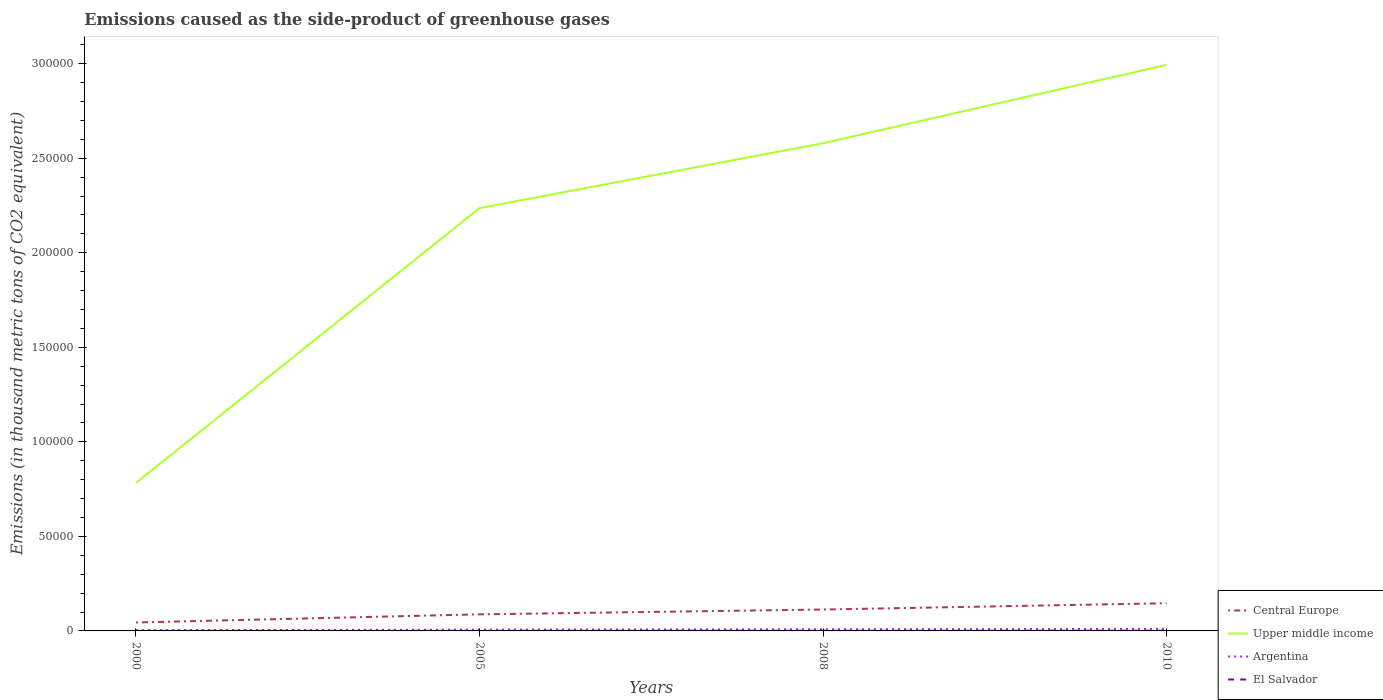Across all years, what is the maximum emissions caused as the side-product of greenhouse gases in El Salvador?
Your response must be concise. 41.4. What is the total emissions caused as the side-product of greenhouse gases in Argentina in the graph?
Provide a short and direct response. -463.6. What is the difference between the highest and the second highest emissions caused as the side-product of greenhouse gases in Central Europe?
Offer a very short reply. 1.02e+04. What is the difference between the highest and the lowest emissions caused as the side-product of greenhouse gases in Central Europe?
Make the answer very short. 2. Is the emissions caused as the side-product of greenhouse gases in Argentina strictly greater than the emissions caused as the side-product of greenhouse gases in Upper middle income over the years?
Offer a terse response. Yes. How many lines are there?
Your answer should be very brief. 4. Are the values on the major ticks of Y-axis written in scientific E-notation?
Make the answer very short. No. Does the graph contain grids?
Make the answer very short. No. How are the legend labels stacked?
Offer a very short reply. Vertical. What is the title of the graph?
Your response must be concise. Emissions caused as the side-product of greenhouse gases. Does "Samoa" appear as one of the legend labels in the graph?
Provide a short and direct response. No. What is the label or title of the X-axis?
Keep it short and to the point. Years. What is the label or title of the Y-axis?
Your answer should be very brief. Emissions (in thousand metric tons of CO2 equivalent). What is the Emissions (in thousand metric tons of CO2 equivalent) of Central Europe in 2000?
Provide a short and direct response. 4466.9. What is the Emissions (in thousand metric tons of CO2 equivalent) of Upper middle income in 2000?
Give a very brief answer. 7.83e+04. What is the Emissions (in thousand metric tons of CO2 equivalent) in Argentina in 2000?
Keep it short and to the point. 408.8. What is the Emissions (in thousand metric tons of CO2 equivalent) in El Salvador in 2000?
Offer a very short reply. 41.4. What is the Emissions (in thousand metric tons of CO2 equivalent) in Central Europe in 2005?
Your answer should be very brief. 8777.6. What is the Emissions (in thousand metric tons of CO2 equivalent) of Upper middle income in 2005?
Offer a terse response. 2.24e+05. What is the Emissions (in thousand metric tons of CO2 equivalent) of Argentina in 2005?
Your answer should be very brief. 664.9. What is the Emissions (in thousand metric tons of CO2 equivalent) in El Salvador in 2005?
Provide a short and direct response. 76.4. What is the Emissions (in thousand metric tons of CO2 equivalent) in Central Europe in 2008?
Give a very brief answer. 1.13e+04. What is the Emissions (in thousand metric tons of CO2 equivalent) of Upper middle income in 2008?
Offer a terse response. 2.58e+05. What is the Emissions (in thousand metric tons of CO2 equivalent) of Argentina in 2008?
Keep it short and to the point. 872.4. What is the Emissions (in thousand metric tons of CO2 equivalent) in El Salvador in 2008?
Offer a very short reply. 99.6. What is the Emissions (in thousand metric tons of CO2 equivalent) in Central Europe in 2010?
Offer a very short reply. 1.46e+04. What is the Emissions (in thousand metric tons of CO2 equivalent) in Upper middle income in 2010?
Provide a short and direct response. 2.99e+05. What is the Emissions (in thousand metric tons of CO2 equivalent) of Argentina in 2010?
Give a very brief answer. 1084. What is the Emissions (in thousand metric tons of CO2 equivalent) in El Salvador in 2010?
Make the answer very short. 116. Across all years, what is the maximum Emissions (in thousand metric tons of CO2 equivalent) in Central Europe?
Your answer should be compact. 1.46e+04. Across all years, what is the maximum Emissions (in thousand metric tons of CO2 equivalent) in Upper middle income?
Your response must be concise. 2.99e+05. Across all years, what is the maximum Emissions (in thousand metric tons of CO2 equivalent) of Argentina?
Give a very brief answer. 1084. Across all years, what is the maximum Emissions (in thousand metric tons of CO2 equivalent) in El Salvador?
Keep it short and to the point. 116. Across all years, what is the minimum Emissions (in thousand metric tons of CO2 equivalent) in Central Europe?
Keep it short and to the point. 4466.9. Across all years, what is the minimum Emissions (in thousand metric tons of CO2 equivalent) of Upper middle income?
Your response must be concise. 7.83e+04. Across all years, what is the minimum Emissions (in thousand metric tons of CO2 equivalent) of Argentina?
Your answer should be compact. 408.8. Across all years, what is the minimum Emissions (in thousand metric tons of CO2 equivalent) in El Salvador?
Your response must be concise. 41.4. What is the total Emissions (in thousand metric tons of CO2 equivalent) of Central Europe in the graph?
Make the answer very short. 3.92e+04. What is the total Emissions (in thousand metric tons of CO2 equivalent) in Upper middle income in the graph?
Give a very brief answer. 8.59e+05. What is the total Emissions (in thousand metric tons of CO2 equivalent) of Argentina in the graph?
Offer a very short reply. 3030.1. What is the total Emissions (in thousand metric tons of CO2 equivalent) in El Salvador in the graph?
Offer a terse response. 333.4. What is the difference between the Emissions (in thousand metric tons of CO2 equivalent) in Central Europe in 2000 and that in 2005?
Your answer should be compact. -4310.7. What is the difference between the Emissions (in thousand metric tons of CO2 equivalent) of Upper middle income in 2000 and that in 2005?
Your response must be concise. -1.45e+05. What is the difference between the Emissions (in thousand metric tons of CO2 equivalent) of Argentina in 2000 and that in 2005?
Make the answer very short. -256.1. What is the difference between the Emissions (in thousand metric tons of CO2 equivalent) of El Salvador in 2000 and that in 2005?
Offer a terse response. -35. What is the difference between the Emissions (in thousand metric tons of CO2 equivalent) of Central Europe in 2000 and that in 2008?
Offer a terse response. -6856.5. What is the difference between the Emissions (in thousand metric tons of CO2 equivalent) of Upper middle income in 2000 and that in 2008?
Provide a succinct answer. -1.80e+05. What is the difference between the Emissions (in thousand metric tons of CO2 equivalent) of Argentina in 2000 and that in 2008?
Make the answer very short. -463.6. What is the difference between the Emissions (in thousand metric tons of CO2 equivalent) in El Salvador in 2000 and that in 2008?
Ensure brevity in your answer.  -58.2. What is the difference between the Emissions (in thousand metric tons of CO2 equivalent) in Central Europe in 2000 and that in 2010?
Make the answer very short. -1.02e+04. What is the difference between the Emissions (in thousand metric tons of CO2 equivalent) of Upper middle income in 2000 and that in 2010?
Offer a very short reply. -2.21e+05. What is the difference between the Emissions (in thousand metric tons of CO2 equivalent) of Argentina in 2000 and that in 2010?
Ensure brevity in your answer.  -675.2. What is the difference between the Emissions (in thousand metric tons of CO2 equivalent) of El Salvador in 2000 and that in 2010?
Provide a succinct answer. -74.6. What is the difference between the Emissions (in thousand metric tons of CO2 equivalent) in Central Europe in 2005 and that in 2008?
Offer a terse response. -2545.8. What is the difference between the Emissions (in thousand metric tons of CO2 equivalent) in Upper middle income in 2005 and that in 2008?
Make the answer very short. -3.43e+04. What is the difference between the Emissions (in thousand metric tons of CO2 equivalent) in Argentina in 2005 and that in 2008?
Provide a succinct answer. -207.5. What is the difference between the Emissions (in thousand metric tons of CO2 equivalent) of El Salvador in 2005 and that in 2008?
Make the answer very short. -23.2. What is the difference between the Emissions (in thousand metric tons of CO2 equivalent) in Central Europe in 2005 and that in 2010?
Your answer should be compact. -5861.4. What is the difference between the Emissions (in thousand metric tons of CO2 equivalent) in Upper middle income in 2005 and that in 2010?
Offer a very short reply. -7.58e+04. What is the difference between the Emissions (in thousand metric tons of CO2 equivalent) of Argentina in 2005 and that in 2010?
Ensure brevity in your answer.  -419.1. What is the difference between the Emissions (in thousand metric tons of CO2 equivalent) in El Salvador in 2005 and that in 2010?
Offer a very short reply. -39.6. What is the difference between the Emissions (in thousand metric tons of CO2 equivalent) of Central Europe in 2008 and that in 2010?
Your response must be concise. -3315.6. What is the difference between the Emissions (in thousand metric tons of CO2 equivalent) in Upper middle income in 2008 and that in 2010?
Provide a short and direct response. -4.14e+04. What is the difference between the Emissions (in thousand metric tons of CO2 equivalent) of Argentina in 2008 and that in 2010?
Offer a terse response. -211.6. What is the difference between the Emissions (in thousand metric tons of CO2 equivalent) of El Salvador in 2008 and that in 2010?
Provide a succinct answer. -16.4. What is the difference between the Emissions (in thousand metric tons of CO2 equivalent) of Central Europe in 2000 and the Emissions (in thousand metric tons of CO2 equivalent) of Upper middle income in 2005?
Keep it short and to the point. -2.19e+05. What is the difference between the Emissions (in thousand metric tons of CO2 equivalent) of Central Europe in 2000 and the Emissions (in thousand metric tons of CO2 equivalent) of Argentina in 2005?
Provide a succinct answer. 3802. What is the difference between the Emissions (in thousand metric tons of CO2 equivalent) of Central Europe in 2000 and the Emissions (in thousand metric tons of CO2 equivalent) of El Salvador in 2005?
Your answer should be compact. 4390.5. What is the difference between the Emissions (in thousand metric tons of CO2 equivalent) of Upper middle income in 2000 and the Emissions (in thousand metric tons of CO2 equivalent) of Argentina in 2005?
Your answer should be compact. 7.76e+04. What is the difference between the Emissions (in thousand metric tons of CO2 equivalent) in Upper middle income in 2000 and the Emissions (in thousand metric tons of CO2 equivalent) in El Salvador in 2005?
Your answer should be very brief. 7.82e+04. What is the difference between the Emissions (in thousand metric tons of CO2 equivalent) in Argentina in 2000 and the Emissions (in thousand metric tons of CO2 equivalent) in El Salvador in 2005?
Provide a succinct answer. 332.4. What is the difference between the Emissions (in thousand metric tons of CO2 equivalent) of Central Europe in 2000 and the Emissions (in thousand metric tons of CO2 equivalent) of Upper middle income in 2008?
Your response must be concise. -2.53e+05. What is the difference between the Emissions (in thousand metric tons of CO2 equivalent) of Central Europe in 2000 and the Emissions (in thousand metric tons of CO2 equivalent) of Argentina in 2008?
Offer a terse response. 3594.5. What is the difference between the Emissions (in thousand metric tons of CO2 equivalent) of Central Europe in 2000 and the Emissions (in thousand metric tons of CO2 equivalent) of El Salvador in 2008?
Ensure brevity in your answer.  4367.3. What is the difference between the Emissions (in thousand metric tons of CO2 equivalent) in Upper middle income in 2000 and the Emissions (in thousand metric tons of CO2 equivalent) in Argentina in 2008?
Your answer should be compact. 7.74e+04. What is the difference between the Emissions (in thousand metric tons of CO2 equivalent) of Upper middle income in 2000 and the Emissions (in thousand metric tons of CO2 equivalent) of El Salvador in 2008?
Give a very brief answer. 7.82e+04. What is the difference between the Emissions (in thousand metric tons of CO2 equivalent) in Argentina in 2000 and the Emissions (in thousand metric tons of CO2 equivalent) in El Salvador in 2008?
Offer a terse response. 309.2. What is the difference between the Emissions (in thousand metric tons of CO2 equivalent) of Central Europe in 2000 and the Emissions (in thousand metric tons of CO2 equivalent) of Upper middle income in 2010?
Your answer should be very brief. -2.95e+05. What is the difference between the Emissions (in thousand metric tons of CO2 equivalent) of Central Europe in 2000 and the Emissions (in thousand metric tons of CO2 equivalent) of Argentina in 2010?
Give a very brief answer. 3382.9. What is the difference between the Emissions (in thousand metric tons of CO2 equivalent) of Central Europe in 2000 and the Emissions (in thousand metric tons of CO2 equivalent) of El Salvador in 2010?
Give a very brief answer. 4350.9. What is the difference between the Emissions (in thousand metric tons of CO2 equivalent) of Upper middle income in 2000 and the Emissions (in thousand metric tons of CO2 equivalent) of Argentina in 2010?
Make the answer very short. 7.72e+04. What is the difference between the Emissions (in thousand metric tons of CO2 equivalent) of Upper middle income in 2000 and the Emissions (in thousand metric tons of CO2 equivalent) of El Salvador in 2010?
Make the answer very short. 7.82e+04. What is the difference between the Emissions (in thousand metric tons of CO2 equivalent) in Argentina in 2000 and the Emissions (in thousand metric tons of CO2 equivalent) in El Salvador in 2010?
Make the answer very short. 292.8. What is the difference between the Emissions (in thousand metric tons of CO2 equivalent) in Central Europe in 2005 and the Emissions (in thousand metric tons of CO2 equivalent) in Upper middle income in 2008?
Keep it short and to the point. -2.49e+05. What is the difference between the Emissions (in thousand metric tons of CO2 equivalent) of Central Europe in 2005 and the Emissions (in thousand metric tons of CO2 equivalent) of Argentina in 2008?
Keep it short and to the point. 7905.2. What is the difference between the Emissions (in thousand metric tons of CO2 equivalent) of Central Europe in 2005 and the Emissions (in thousand metric tons of CO2 equivalent) of El Salvador in 2008?
Offer a very short reply. 8678. What is the difference between the Emissions (in thousand metric tons of CO2 equivalent) in Upper middle income in 2005 and the Emissions (in thousand metric tons of CO2 equivalent) in Argentina in 2008?
Give a very brief answer. 2.23e+05. What is the difference between the Emissions (in thousand metric tons of CO2 equivalent) of Upper middle income in 2005 and the Emissions (in thousand metric tons of CO2 equivalent) of El Salvador in 2008?
Your response must be concise. 2.24e+05. What is the difference between the Emissions (in thousand metric tons of CO2 equivalent) in Argentina in 2005 and the Emissions (in thousand metric tons of CO2 equivalent) in El Salvador in 2008?
Your response must be concise. 565.3. What is the difference between the Emissions (in thousand metric tons of CO2 equivalent) of Central Europe in 2005 and the Emissions (in thousand metric tons of CO2 equivalent) of Upper middle income in 2010?
Your answer should be compact. -2.91e+05. What is the difference between the Emissions (in thousand metric tons of CO2 equivalent) of Central Europe in 2005 and the Emissions (in thousand metric tons of CO2 equivalent) of Argentina in 2010?
Provide a short and direct response. 7693.6. What is the difference between the Emissions (in thousand metric tons of CO2 equivalent) in Central Europe in 2005 and the Emissions (in thousand metric tons of CO2 equivalent) in El Salvador in 2010?
Ensure brevity in your answer.  8661.6. What is the difference between the Emissions (in thousand metric tons of CO2 equivalent) of Upper middle income in 2005 and the Emissions (in thousand metric tons of CO2 equivalent) of Argentina in 2010?
Provide a succinct answer. 2.23e+05. What is the difference between the Emissions (in thousand metric tons of CO2 equivalent) in Upper middle income in 2005 and the Emissions (in thousand metric tons of CO2 equivalent) in El Salvador in 2010?
Your answer should be very brief. 2.24e+05. What is the difference between the Emissions (in thousand metric tons of CO2 equivalent) of Argentina in 2005 and the Emissions (in thousand metric tons of CO2 equivalent) of El Salvador in 2010?
Provide a succinct answer. 548.9. What is the difference between the Emissions (in thousand metric tons of CO2 equivalent) of Central Europe in 2008 and the Emissions (in thousand metric tons of CO2 equivalent) of Upper middle income in 2010?
Provide a short and direct response. -2.88e+05. What is the difference between the Emissions (in thousand metric tons of CO2 equivalent) of Central Europe in 2008 and the Emissions (in thousand metric tons of CO2 equivalent) of Argentina in 2010?
Give a very brief answer. 1.02e+04. What is the difference between the Emissions (in thousand metric tons of CO2 equivalent) of Central Europe in 2008 and the Emissions (in thousand metric tons of CO2 equivalent) of El Salvador in 2010?
Keep it short and to the point. 1.12e+04. What is the difference between the Emissions (in thousand metric tons of CO2 equivalent) in Upper middle income in 2008 and the Emissions (in thousand metric tons of CO2 equivalent) in Argentina in 2010?
Give a very brief answer. 2.57e+05. What is the difference between the Emissions (in thousand metric tons of CO2 equivalent) of Upper middle income in 2008 and the Emissions (in thousand metric tons of CO2 equivalent) of El Salvador in 2010?
Keep it short and to the point. 2.58e+05. What is the difference between the Emissions (in thousand metric tons of CO2 equivalent) in Argentina in 2008 and the Emissions (in thousand metric tons of CO2 equivalent) in El Salvador in 2010?
Keep it short and to the point. 756.4. What is the average Emissions (in thousand metric tons of CO2 equivalent) of Central Europe per year?
Your answer should be compact. 9801.73. What is the average Emissions (in thousand metric tons of CO2 equivalent) in Upper middle income per year?
Provide a succinct answer. 2.15e+05. What is the average Emissions (in thousand metric tons of CO2 equivalent) of Argentina per year?
Keep it short and to the point. 757.52. What is the average Emissions (in thousand metric tons of CO2 equivalent) in El Salvador per year?
Your answer should be very brief. 83.35. In the year 2000, what is the difference between the Emissions (in thousand metric tons of CO2 equivalent) in Central Europe and Emissions (in thousand metric tons of CO2 equivalent) in Upper middle income?
Give a very brief answer. -7.38e+04. In the year 2000, what is the difference between the Emissions (in thousand metric tons of CO2 equivalent) of Central Europe and Emissions (in thousand metric tons of CO2 equivalent) of Argentina?
Provide a short and direct response. 4058.1. In the year 2000, what is the difference between the Emissions (in thousand metric tons of CO2 equivalent) in Central Europe and Emissions (in thousand metric tons of CO2 equivalent) in El Salvador?
Offer a very short reply. 4425.5. In the year 2000, what is the difference between the Emissions (in thousand metric tons of CO2 equivalent) in Upper middle income and Emissions (in thousand metric tons of CO2 equivalent) in Argentina?
Offer a very short reply. 7.79e+04. In the year 2000, what is the difference between the Emissions (in thousand metric tons of CO2 equivalent) in Upper middle income and Emissions (in thousand metric tons of CO2 equivalent) in El Salvador?
Your answer should be compact. 7.82e+04. In the year 2000, what is the difference between the Emissions (in thousand metric tons of CO2 equivalent) in Argentina and Emissions (in thousand metric tons of CO2 equivalent) in El Salvador?
Keep it short and to the point. 367.4. In the year 2005, what is the difference between the Emissions (in thousand metric tons of CO2 equivalent) in Central Europe and Emissions (in thousand metric tons of CO2 equivalent) in Upper middle income?
Ensure brevity in your answer.  -2.15e+05. In the year 2005, what is the difference between the Emissions (in thousand metric tons of CO2 equivalent) of Central Europe and Emissions (in thousand metric tons of CO2 equivalent) of Argentina?
Your answer should be very brief. 8112.7. In the year 2005, what is the difference between the Emissions (in thousand metric tons of CO2 equivalent) in Central Europe and Emissions (in thousand metric tons of CO2 equivalent) in El Salvador?
Give a very brief answer. 8701.2. In the year 2005, what is the difference between the Emissions (in thousand metric tons of CO2 equivalent) of Upper middle income and Emissions (in thousand metric tons of CO2 equivalent) of Argentina?
Keep it short and to the point. 2.23e+05. In the year 2005, what is the difference between the Emissions (in thousand metric tons of CO2 equivalent) of Upper middle income and Emissions (in thousand metric tons of CO2 equivalent) of El Salvador?
Your answer should be compact. 2.24e+05. In the year 2005, what is the difference between the Emissions (in thousand metric tons of CO2 equivalent) of Argentina and Emissions (in thousand metric tons of CO2 equivalent) of El Salvador?
Keep it short and to the point. 588.5. In the year 2008, what is the difference between the Emissions (in thousand metric tons of CO2 equivalent) in Central Europe and Emissions (in thousand metric tons of CO2 equivalent) in Upper middle income?
Your answer should be compact. -2.47e+05. In the year 2008, what is the difference between the Emissions (in thousand metric tons of CO2 equivalent) of Central Europe and Emissions (in thousand metric tons of CO2 equivalent) of Argentina?
Provide a succinct answer. 1.05e+04. In the year 2008, what is the difference between the Emissions (in thousand metric tons of CO2 equivalent) of Central Europe and Emissions (in thousand metric tons of CO2 equivalent) of El Salvador?
Make the answer very short. 1.12e+04. In the year 2008, what is the difference between the Emissions (in thousand metric tons of CO2 equivalent) in Upper middle income and Emissions (in thousand metric tons of CO2 equivalent) in Argentina?
Provide a succinct answer. 2.57e+05. In the year 2008, what is the difference between the Emissions (in thousand metric tons of CO2 equivalent) in Upper middle income and Emissions (in thousand metric tons of CO2 equivalent) in El Salvador?
Provide a short and direct response. 2.58e+05. In the year 2008, what is the difference between the Emissions (in thousand metric tons of CO2 equivalent) in Argentina and Emissions (in thousand metric tons of CO2 equivalent) in El Salvador?
Offer a very short reply. 772.8. In the year 2010, what is the difference between the Emissions (in thousand metric tons of CO2 equivalent) of Central Europe and Emissions (in thousand metric tons of CO2 equivalent) of Upper middle income?
Offer a very short reply. -2.85e+05. In the year 2010, what is the difference between the Emissions (in thousand metric tons of CO2 equivalent) in Central Europe and Emissions (in thousand metric tons of CO2 equivalent) in Argentina?
Your answer should be very brief. 1.36e+04. In the year 2010, what is the difference between the Emissions (in thousand metric tons of CO2 equivalent) in Central Europe and Emissions (in thousand metric tons of CO2 equivalent) in El Salvador?
Provide a short and direct response. 1.45e+04. In the year 2010, what is the difference between the Emissions (in thousand metric tons of CO2 equivalent) of Upper middle income and Emissions (in thousand metric tons of CO2 equivalent) of Argentina?
Provide a short and direct response. 2.98e+05. In the year 2010, what is the difference between the Emissions (in thousand metric tons of CO2 equivalent) in Upper middle income and Emissions (in thousand metric tons of CO2 equivalent) in El Salvador?
Your response must be concise. 2.99e+05. In the year 2010, what is the difference between the Emissions (in thousand metric tons of CO2 equivalent) in Argentina and Emissions (in thousand metric tons of CO2 equivalent) in El Salvador?
Offer a very short reply. 968. What is the ratio of the Emissions (in thousand metric tons of CO2 equivalent) in Central Europe in 2000 to that in 2005?
Your answer should be compact. 0.51. What is the ratio of the Emissions (in thousand metric tons of CO2 equivalent) of Upper middle income in 2000 to that in 2005?
Your answer should be very brief. 0.35. What is the ratio of the Emissions (in thousand metric tons of CO2 equivalent) in Argentina in 2000 to that in 2005?
Provide a short and direct response. 0.61. What is the ratio of the Emissions (in thousand metric tons of CO2 equivalent) of El Salvador in 2000 to that in 2005?
Provide a succinct answer. 0.54. What is the ratio of the Emissions (in thousand metric tons of CO2 equivalent) in Central Europe in 2000 to that in 2008?
Give a very brief answer. 0.39. What is the ratio of the Emissions (in thousand metric tons of CO2 equivalent) in Upper middle income in 2000 to that in 2008?
Make the answer very short. 0.3. What is the ratio of the Emissions (in thousand metric tons of CO2 equivalent) in Argentina in 2000 to that in 2008?
Provide a short and direct response. 0.47. What is the ratio of the Emissions (in thousand metric tons of CO2 equivalent) in El Salvador in 2000 to that in 2008?
Your answer should be very brief. 0.42. What is the ratio of the Emissions (in thousand metric tons of CO2 equivalent) in Central Europe in 2000 to that in 2010?
Give a very brief answer. 0.31. What is the ratio of the Emissions (in thousand metric tons of CO2 equivalent) in Upper middle income in 2000 to that in 2010?
Give a very brief answer. 0.26. What is the ratio of the Emissions (in thousand metric tons of CO2 equivalent) in Argentina in 2000 to that in 2010?
Provide a succinct answer. 0.38. What is the ratio of the Emissions (in thousand metric tons of CO2 equivalent) in El Salvador in 2000 to that in 2010?
Offer a terse response. 0.36. What is the ratio of the Emissions (in thousand metric tons of CO2 equivalent) of Central Europe in 2005 to that in 2008?
Offer a very short reply. 0.78. What is the ratio of the Emissions (in thousand metric tons of CO2 equivalent) in Upper middle income in 2005 to that in 2008?
Offer a very short reply. 0.87. What is the ratio of the Emissions (in thousand metric tons of CO2 equivalent) of Argentina in 2005 to that in 2008?
Make the answer very short. 0.76. What is the ratio of the Emissions (in thousand metric tons of CO2 equivalent) in El Salvador in 2005 to that in 2008?
Offer a very short reply. 0.77. What is the ratio of the Emissions (in thousand metric tons of CO2 equivalent) in Central Europe in 2005 to that in 2010?
Ensure brevity in your answer.  0.6. What is the ratio of the Emissions (in thousand metric tons of CO2 equivalent) of Upper middle income in 2005 to that in 2010?
Provide a short and direct response. 0.75. What is the ratio of the Emissions (in thousand metric tons of CO2 equivalent) in Argentina in 2005 to that in 2010?
Ensure brevity in your answer.  0.61. What is the ratio of the Emissions (in thousand metric tons of CO2 equivalent) of El Salvador in 2005 to that in 2010?
Give a very brief answer. 0.66. What is the ratio of the Emissions (in thousand metric tons of CO2 equivalent) in Central Europe in 2008 to that in 2010?
Offer a terse response. 0.77. What is the ratio of the Emissions (in thousand metric tons of CO2 equivalent) of Upper middle income in 2008 to that in 2010?
Your answer should be compact. 0.86. What is the ratio of the Emissions (in thousand metric tons of CO2 equivalent) in Argentina in 2008 to that in 2010?
Make the answer very short. 0.8. What is the ratio of the Emissions (in thousand metric tons of CO2 equivalent) in El Salvador in 2008 to that in 2010?
Provide a short and direct response. 0.86. What is the difference between the highest and the second highest Emissions (in thousand metric tons of CO2 equivalent) of Central Europe?
Provide a succinct answer. 3315.6. What is the difference between the highest and the second highest Emissions (in thousand metric tons of CO2 equivalent) of Upper middle income?
Offer a very short reply. 4.14e+04. What is the difference between the highest and the second highest Emissions (in thousand metric tons of CO2 equivalent) of Argentina?
Provide a succinct answer. 211.6. What is the difference between the highest and the second highest Emissions (in thousand metric tons of CO2 equivalent) of El Salvador?
Give a very brief answer. 16.4. What is the difference between the highest and the lowest Emissions (in thousand metric tons of CO2 equivalent) in Central Europe?
Offer a terse response. 1.02e+04. What is the difference between the highest and the lowest Emissions (in thousand metric tons of CO2 equivalent) of Upper middle income?
Offer a terse response. 2.21e+05. What is the difference between the highest and the lowest Emissions (in thousand metric tons of CO2 equivalent) of Argentina?
Provide a succinct answer. 675.2. What is the difference between the highest and the lowest Emissions (in thousand metric tons of CO2 equivalent) of El Salvador?
Offer a very short reply. 74.6. 